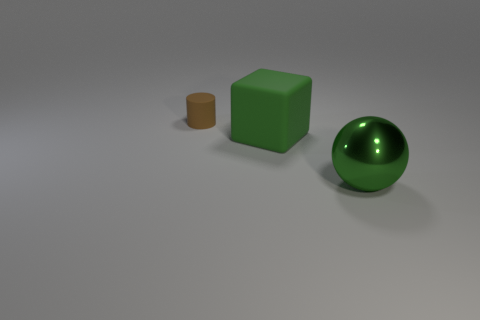Add 2 big brown matte spheres. How many objects exist? 5 Subtract all balls. How many objects are left? 2 Subtract 0 yellow balls. How many objects are left? 3 Subtract all brown matte balls. Subtract all big green things. How many objects are left? 1 Add 1 metallic things. How many metallic things are left? 2 Add 2 blue metal blocks. How many blue metal blocks exist? 2 